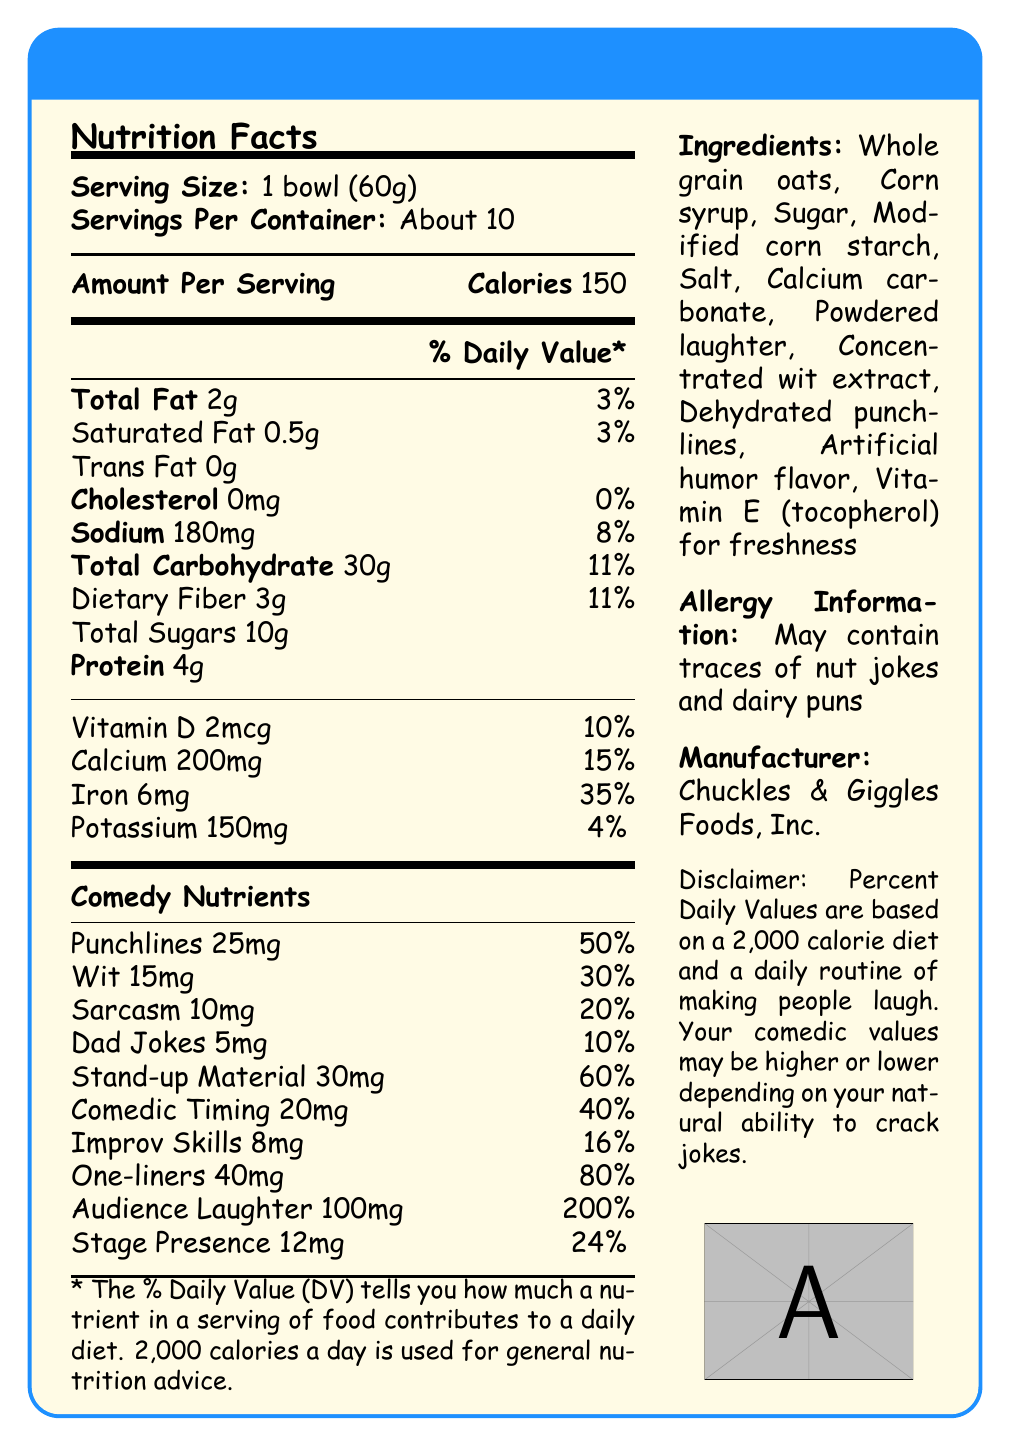what is the serving size? According to the document, the serving size is listed as "1 bowl (60g)".
Answer: 1 bowl (60g) How many servings are there per container? The document specifies that there are "About 10" servings per container.
Answer: About 10 How many calories are in one serving? The document shows that each serving contains 150 calories.
Answer: 150 How much sodium is in one serving? The sodium content per serving is listed as 180mg in the document.
Answer: 180mg What percentage of Daily Value does 1 bowl of Comedian's Cereal provide for Iron? The document displays that one serving provides 35% of the Daily Value for Iron.
Answer: 35% what are the main ingredients? The main ingredients are listed in the ingredient section of the document.
Answer: Whole grain oats, Corn syrup, Sugar, Modified corn starch, Salt, Calcium carbonate, Powdered laughter, Concentrated wit extract, Dehydrated punchlines, Artificial humor flavor, Vitamin E (tocopherol) for freshness What company manufactures Comedian's Cereal? The document states that Chuckles & Giggles Foods, Inc. is the manufacturer.
Answer: Chuckles & Giggles Foods, Inc. Does the document indicate if there are any allergens in the cereal? The document includes an allergy information section that states it "May contain traces of nut jokes and dairy puns."
Answer: Yes What is the highest percentage Daily Value in the Comedy Nutrients section? A. Punchlines B. Audience Laughter C. One-liners D. Stand-up Material The document shows that Audience Laughter has a 200% Daily Value, which is the highest in the Comedy Nutrients section.
Answer: B. Audience Laughter How much dietary fiber is in each serving? A. 1g B. 2g C. 3g D. 4g Each serving contains 3g of dietary fiber according to the document.
Answer: C. 3g What nutrient provides a 10% Daily Value in the Comedy Nutrients section? A. Punchlines B. Wit C. Dad Jokes D. Stage Presence The Daily Value for Dad Jokes in the document is listed as 10%.
Answer: C. Dad Jokes Are there any trans fats in the cereal? The document indicates that the cereal has 0g of Trans Fat.
Answer: No Summarize the content and purpose of the document. The document is designed to inform consumers about the nutritional content of a fictional cereal that includes comedic elements, emphasizing both typical nutritional facts and humor-related "nutrients" to align with the product's playful branding.
Answer: The document is a Nutrition Facts Label for "Comedian's Cereal," providing detailed nutritional information per serving, including calorie count, fat, sugars, vitamins, and comedy-related nutrients like Punchlines and Audience Laughter. It also lists ingredients, allergen information, and the manufacturer. How much Comedic Timing does one serving have? The document notes that one serving provides 20mg of Comedic Timing.
Answer: 20mg What are the Daily Values for both Punchlines and Wit combined? Punchlines have a Daily Value of 50% and Wit has 30%, combining to a total of 80%.
Answer: 80% What is the purpose of Vitamin E in this cereal? According to the ingredients list in the document, Vitamin E (tocopherol) is included for freshness.
Answer: For freshness Does the document provide a specific formula or method for calculating the % Daily Values? The document includes a disclaimer that the % Daily Values are based on a 2,000-calorie diet, but it does not provide a specific formula or method for calculating them.
Answer: No What is the total amount of sugars in one serving? The document lists that one serving contains 10g of total sugars.
Answer: 10g 